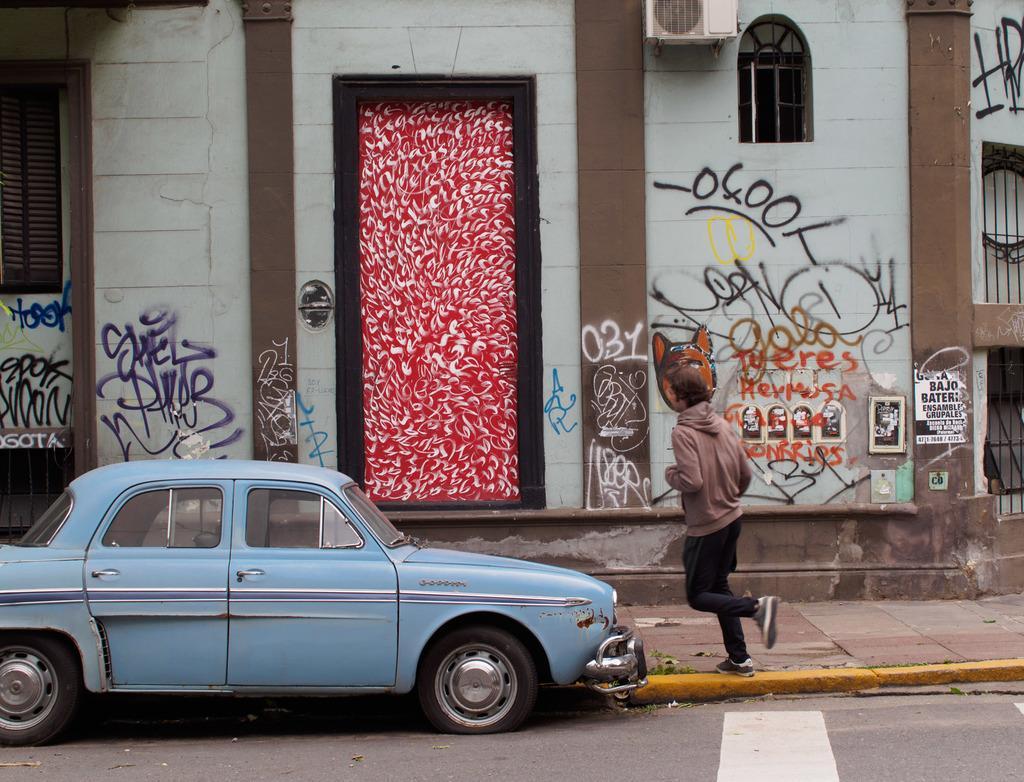How would you summarize this image in a sentence or two? A car is on the road, a person is walking, there is a building with the window and a door. 